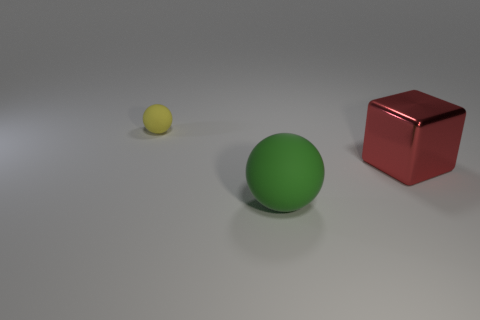Add 3 small yellow balls. How many objects exist? 6 Subtract all blocks. How many objects are left? 2 Subtract 1 yellow balls. How many objects are left? 2 Subtract all small things. Subtract all big cyan metal things. How many objects are left? 2 Add 1 green rubber objects. How many green rubber objects are left? 2 Add 2 big green matte spheres. How many big green matte spheres exist? 3 